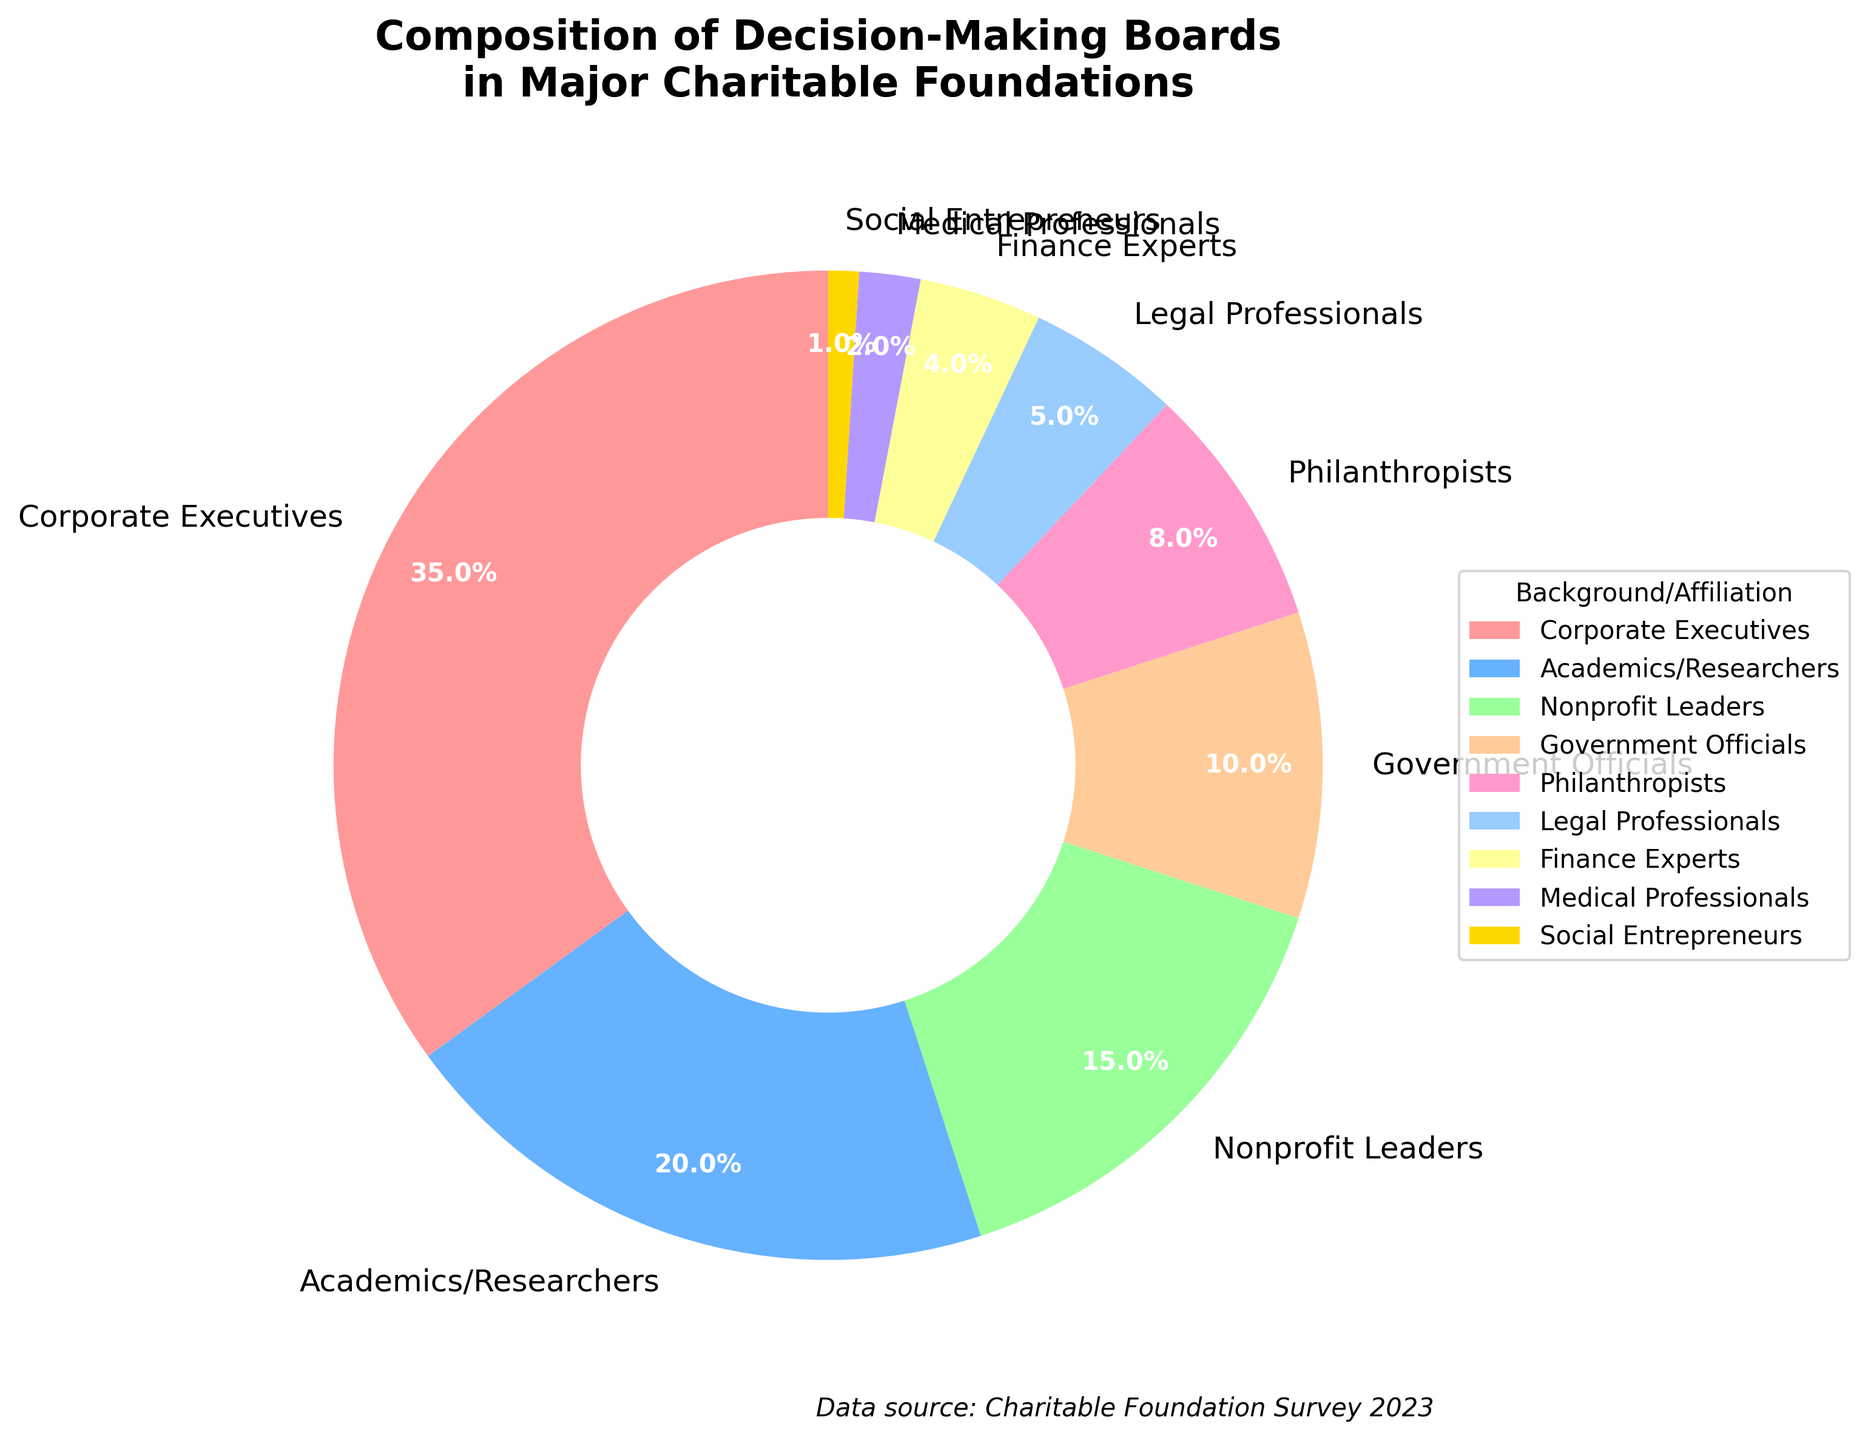Which background/affiliation has the highest representation on the decision-making boards? The figure shows a pie chart where the segment for Corporate Executives is the largest.
Answer: Corporate Executives What percentage of the decision-making boards do Nonprofit Leaders and Government Officials collectively represent? According to the pie chart, Nonprofit Leaders represent 15% and Government Officials represent 10%. Adding these together gives 15% + 10% = 25%.
Answer: 25% Is the combined percentage of Philanthropists and Legal Professionals greater than that of Academics/Researchers? Philanthropists account for 8%, and Legal Professionals for 5%. Adding these together gives 8% + 5% = 13%. Academics/Researchers account for 20%. Comparing the two values, 13% is less than 20%.
Answer: No Which group has a lower representation: Finance Experts or Medical Professionals? The pie chart shows that Finance Experts represent 4%, while Medical Professionals represent 2%. Therefore, Medical Professionals have a lower representation.
Answer: Medical Professionals What is the difference in percentage between Social Entrepreneurs and Government Officials? Social Entrepreneurs have a 1% representation, while Government Officials have a 10% representation. The difference is 10% - 1% = 9%.
Answer: 9% Which color represents the Academics/Researchers in the pie chart? Academics/Researchers are shown with a blue segment in the pie chart.
Answer: blue Adding the percentages of Corporate Executives, Nonprofit Leaders, and Philanthropists gives what proportion of the decision-making boards? Corporate Executives represent 35%, Nonprofit Leaders 15%, and Philanthropists 8%. Summing these gives 35% + 15% + 8% = 58%.
Answer: 58% Are there more segments representing professional backgrounds or sectors the individuals are affiliated with? The chart provides background/affiliation categories which include Corporate Executives, Academics/Researchers, Nonprofit Leaders, Government Officials, Philanthropists, Legal Professionals, Finance Experts, Medical Professionals, and Social Entrepreneurs. These categories can be viewed as professional backgrounds rather than sectors.
Answer: professional backgrounds What is the second most represented background/affiliation on the decision-making boards? The pie chart indicates Academics/Researchers have the second largest segment, representing 20%.
Answer: Academics/Researchers 